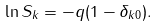<formula> <loc_0><loc_0><loc_500><loc_500>\ln S _ { k } = - q ( 1 - \delta _ { k 0 } ) .</formula> 